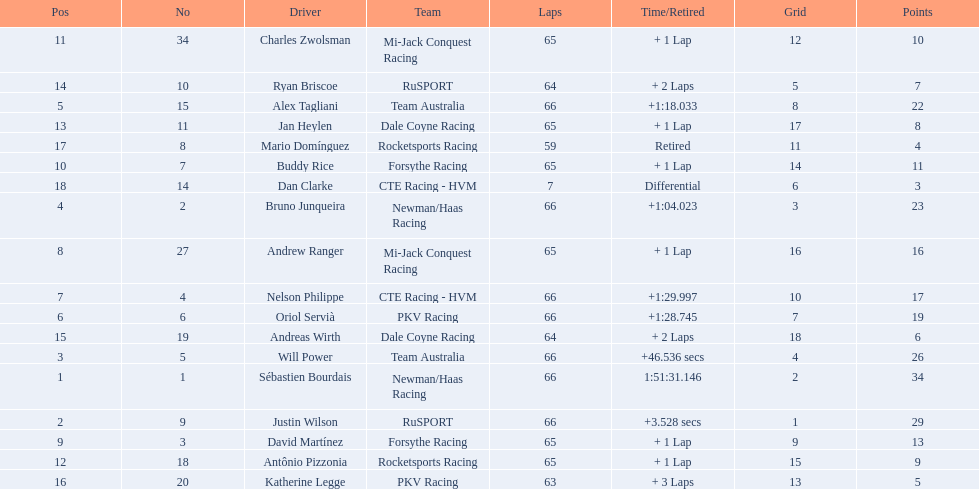How many points did first place receive? 34. How many did last place receive? 3. Who was the recipient of these last place points? Dan Clarke. 